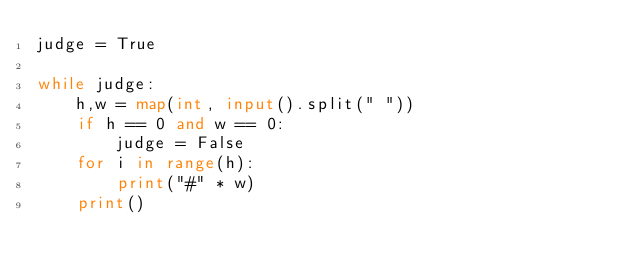Convert code to text. <code><loc_0><loc_0><loc_500><loc_500><_Python_>judge = True

while judge:
    h,w = map(int, input().split(" "))
    if h == 0 and w == 0:
        judge = False
    for i in range(h):
        print("#" * w)
    print()</code> 